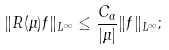Convert formula to latex. <formula><loc_0><loc_0><loc_500><loc_500>\| R ( \mu ) f \| _ { L ^ { \infty } } \leq \frac { C _ { \alpha } } { | \mu | } \| f \| _ { L ^ { \infty } } ;</formula> 